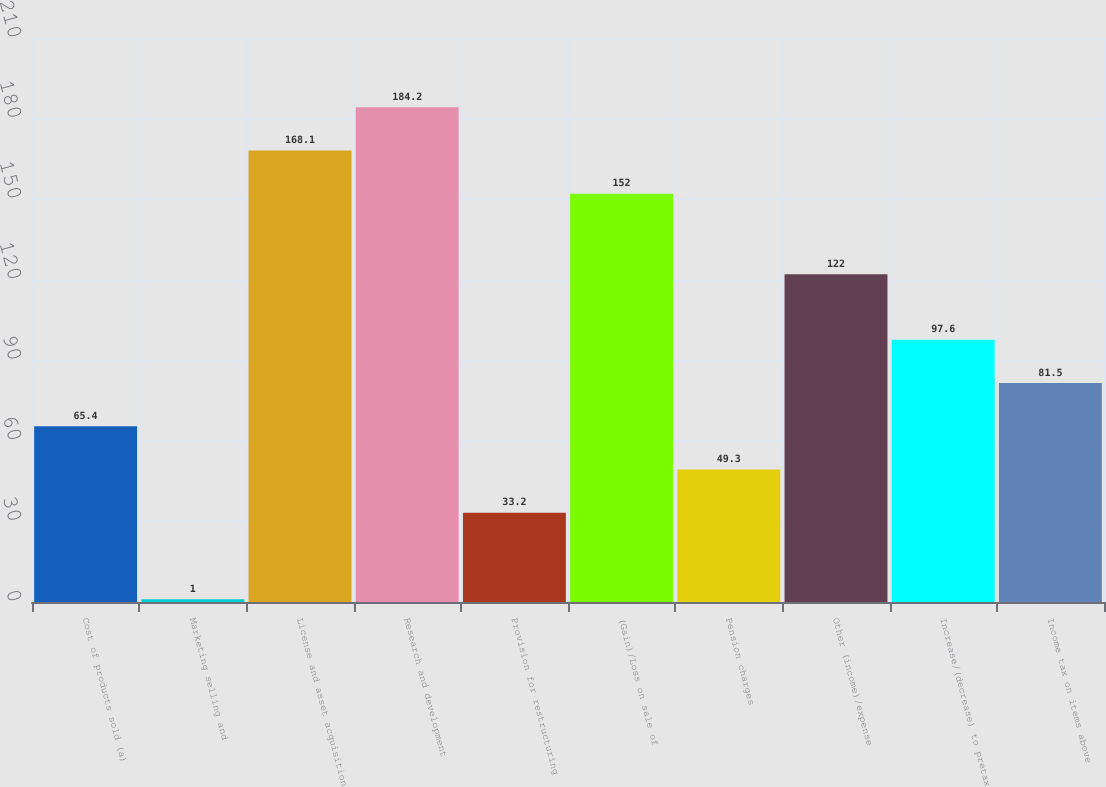Convert chart to OTSL. <chart><loc_0><loc_0><loc_500><loc_500><bar_chart><fcel>Cost of products sold (a)<fcel>Marketing selling and<fcel>License and asset acquisition<fcel>Research and development<fcel>Provision for restructuring<fcel>(Gain)/Loss on sale of<fcel>Pension charges<fcel>Other (income)/expense<fcel>Increase/(decrease) to pretax<fcel>Income tax on items above<nl><fcel>65.4<fcel>1<fcel>168.1<fcel>184.2<fcel>33.2<fcel>152<fcel>49.3<fcel>122<fcel>97.6<fcel>81.5<nl></chart> 